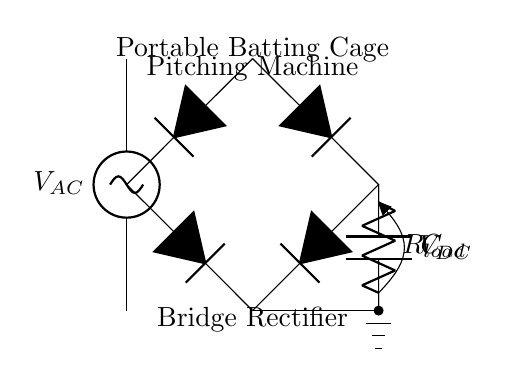What type of rectifier is used in this circuit? This circuit diagram represents a bridge rectifier, which is evident from the arrangement of four diodes connected in a bridge configuration. This is a standard design for converting AC to DC.
Answer: bridge rectifier What does the load resistor symbolize in this circuit? The load resistor represents the device or component that uses the DC output provided by the rectifier. It is essential for limiting the current in the circuit and ensuring the proper operation of the connected device.
Answer: R load What is the purpose of the capacitor in this circuit? The capacitor serves to smooth the output voltage after rectification. It helps in reducing the ripple voltage, resulting in a more stable and constant DC voltage for the load.
Answer: smoothing Which component converts AC voltage to DC voltage in this circuit? The diodes in the bridge rectifier are responsible for converting AC voltage to DC voltage. They allow current to flow only in one direction, effectively rectifying the AC signal.
Answer: diodes How many diodes are there in this bridge rectifier? The bridge rectifier consists of four diodes, which are arranged to ensure that both halves of the AC waveform are utilized and converted to DC.
Answer: four What is the input voltage type for this circuit? The input voltage is AC, as indicated by the label on the AC voltage source in the circuit diagram. This reflects the nature of the voltage that needs to be rectified.
Answer: AC What does the label V DC refer to in this circuit? V DC refers to the output voltage from the rectifier, which is the direct current voltage obtained after rectification of the input AC voltage. This is the voltage that is supplied to the load.
Answer: V DC 